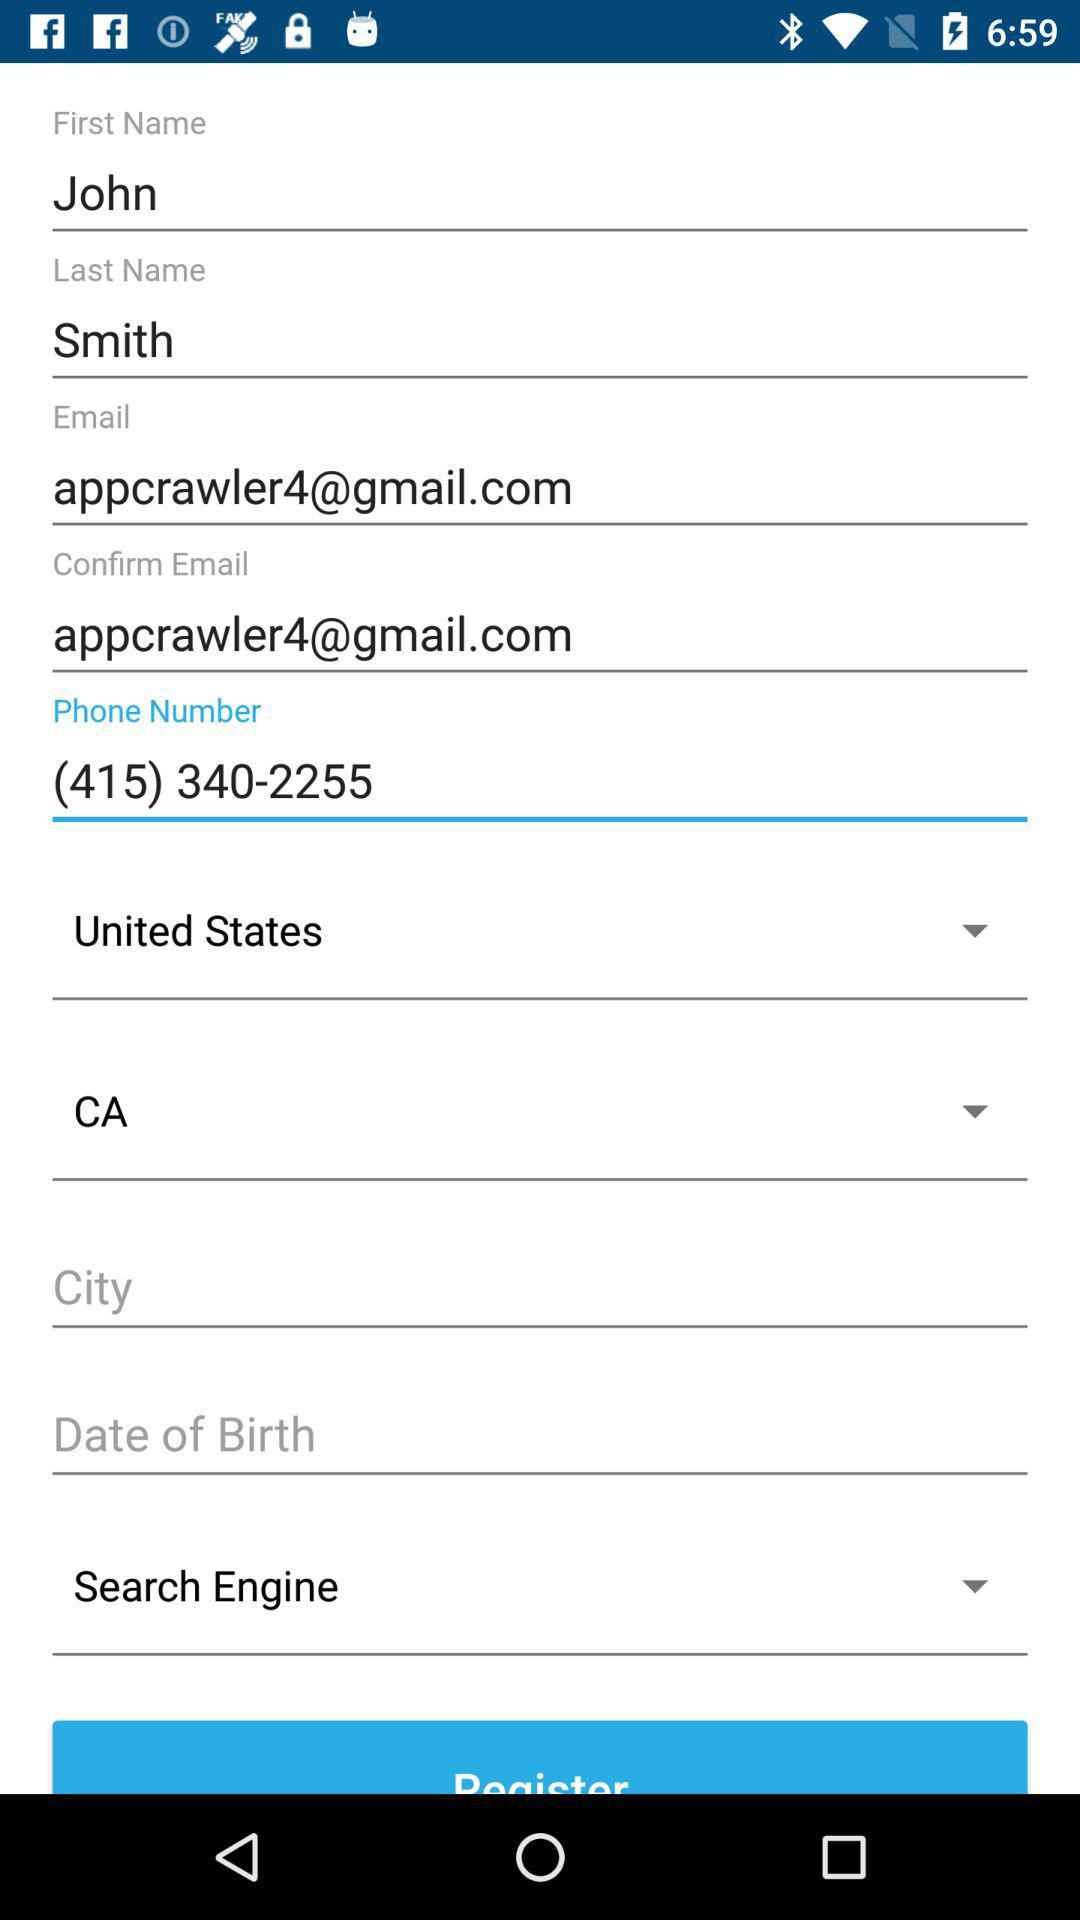How many text fields have an email address?
Answer the question using a single word or phrase. 2 